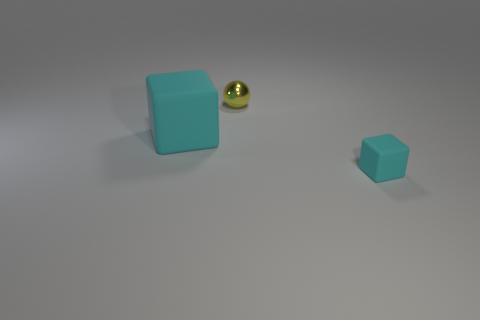Add 1 big matte cylinders. How many objects exist? 4 Subtract all cubes. How many objects are left? 1 Add 2 tiny shiny balls. How many tiny shiny balls are left? 3 Add 2 small gray cylinders. How many small gray cylinders exist? 2 Subtract 0 red balls. How many objects are left? 3 Subtract all gray spheres. Subtract all yellow cylinders. How many spheres are left? 1 Subtract all tiny shiny objects. Subtract all tiny rubber blocks. How many objects are left? 1 